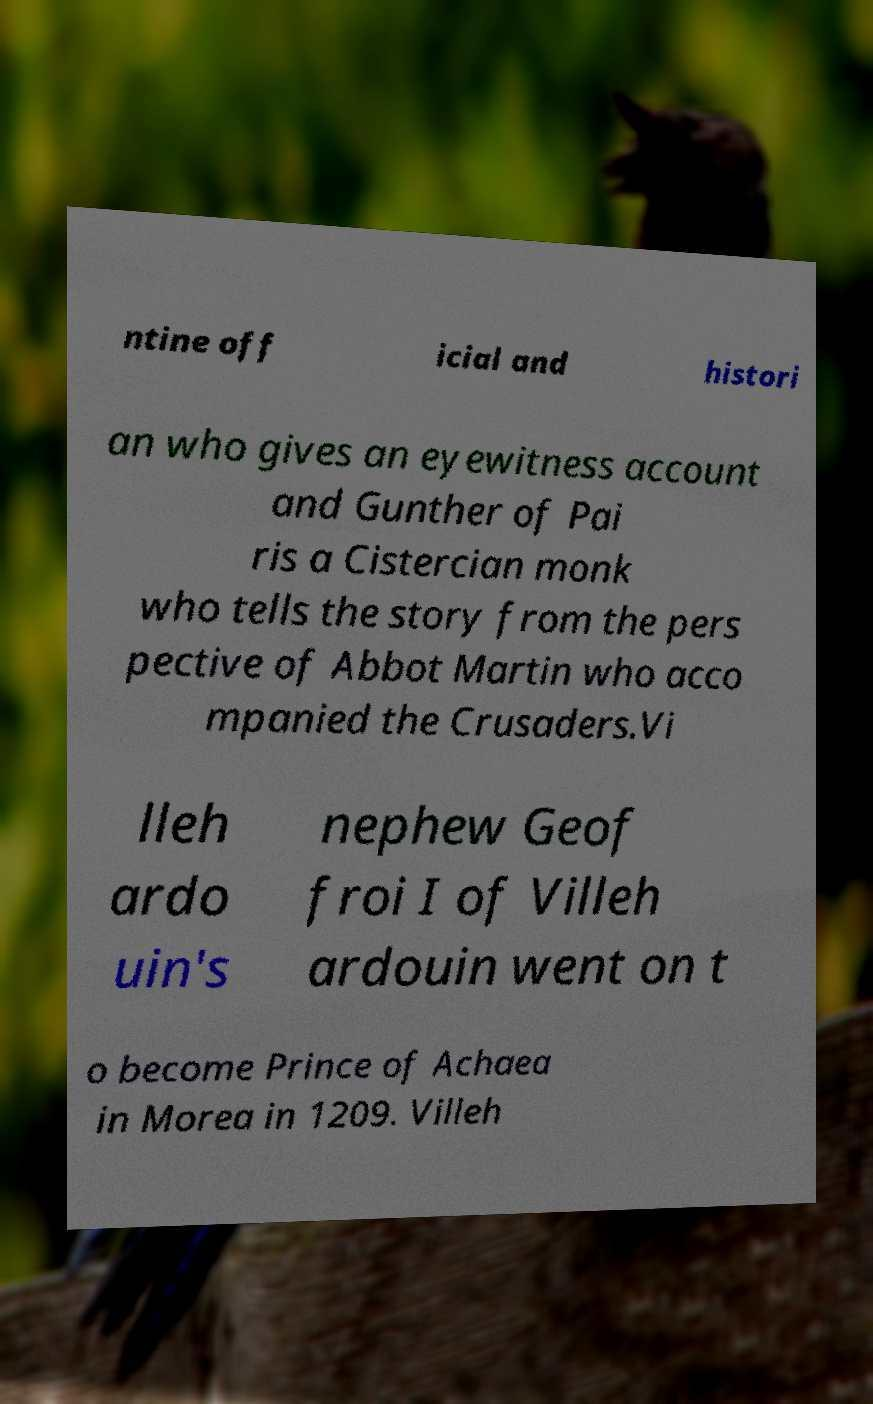Please read and relay the text visible in this image. What does it say? ntine off icial and histori an who gives an eyewitness account and Gunther of Pai ris a Cistercian monk who tells the story from the pers pective of Abbot Martin who acco mpanied the Crusaders.Vi lleh ardo uin's nephew Geof froi I of Villeh ardouin went on t o become Prince of Achaea in Morea in 1209. Villeh 